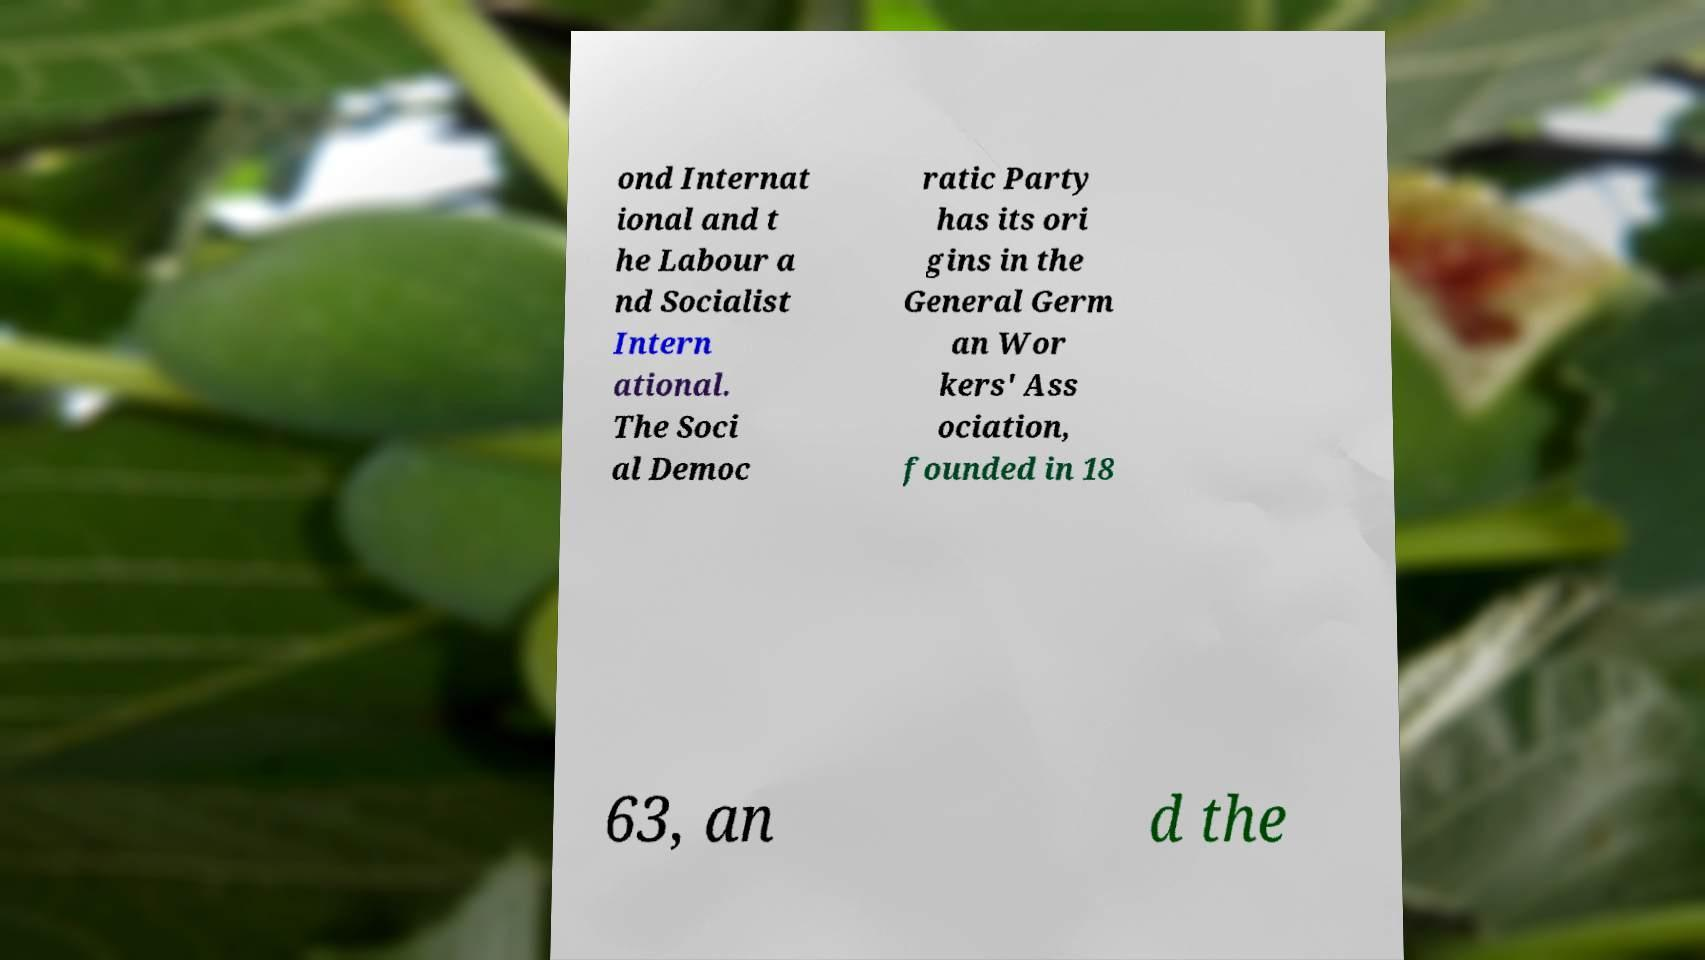For documentation purposes, I need the text within this image transcribed. Could you provide that? ond Internat ional and t he Labour a nd Socialist Intern ational. The Soci al Democ ratic Party has its ori gins in the General Germ an Wor kers' Ass ociation, founded in 18 63, an d the 